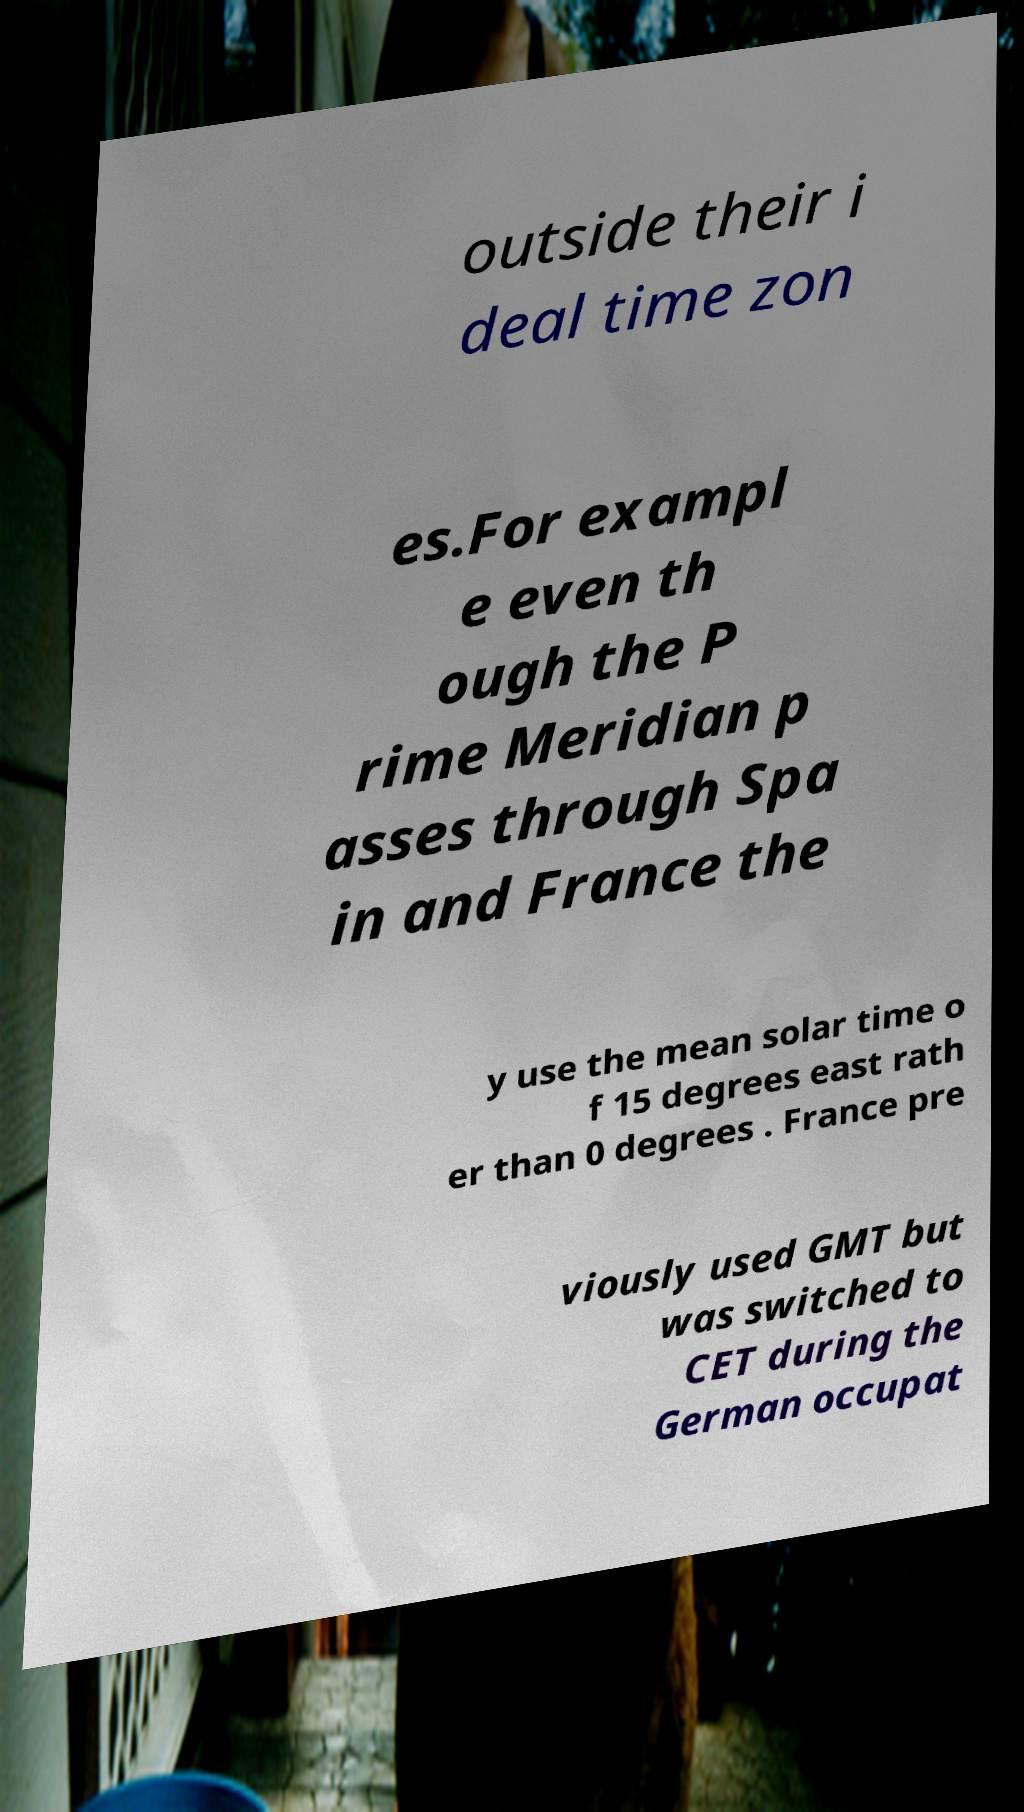Could you assist in decoding the text presented in this image and type it out clearly? outside their i deal time zon es.For exampl e even th ough the P rime Meridian p asses through Spa in and France the y use the mean solar time o f 15 degrees east rath er than 0 degrees . France pre viously used GMT but was switched to CET during the German occupat 